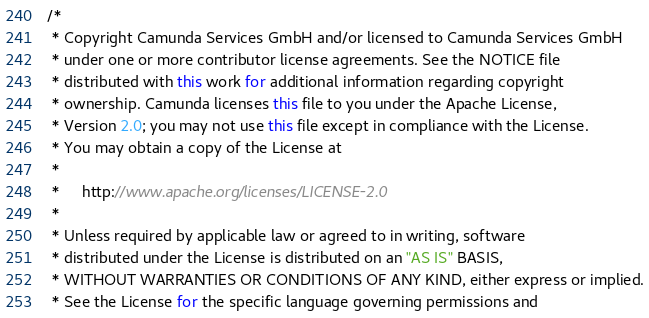<code> <loc_0><loc_0><loc_500><loc_500><_Java_>/*
 * Copyright Camunda Services GmbH and/or licensed to Camunda Services GmbH
 * under one or more contributor license agreements. See the NOTICE file
 * distributed with this work for additional information regarding copyright
 * ownership. Camunda licenses this file to you under the Apache License,
 * Version 2.0; you may not use this file except in compliance with the License.
 * You may obtain a copy of the License at
 *
 *     http://www.apache.org/licenses/LICENSE-2.0
 *
 * Unless required by applicable law or agreed to in writing, software
 * distributed under the License is distributed on an "AS IS" BASIS,
 * WITHOUT WARRANTIES OR CONDITIONS OF ANY KIND, either express or implied.
 * See the License for the specific language governing permissions and</code> 